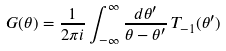<formula> <loc_0><loc_0><loc_500><loc_500>G ( \theta ) = \frac { 1 } { 2 \pi i } \int _ { - \infty } ^ { \infty } \frac { d \theta ^ { \prime } } { \theta - \theta ^ { \prime } } \, T _ { - 1 } ( \theta ^ { \prime } ) \,</formula> 